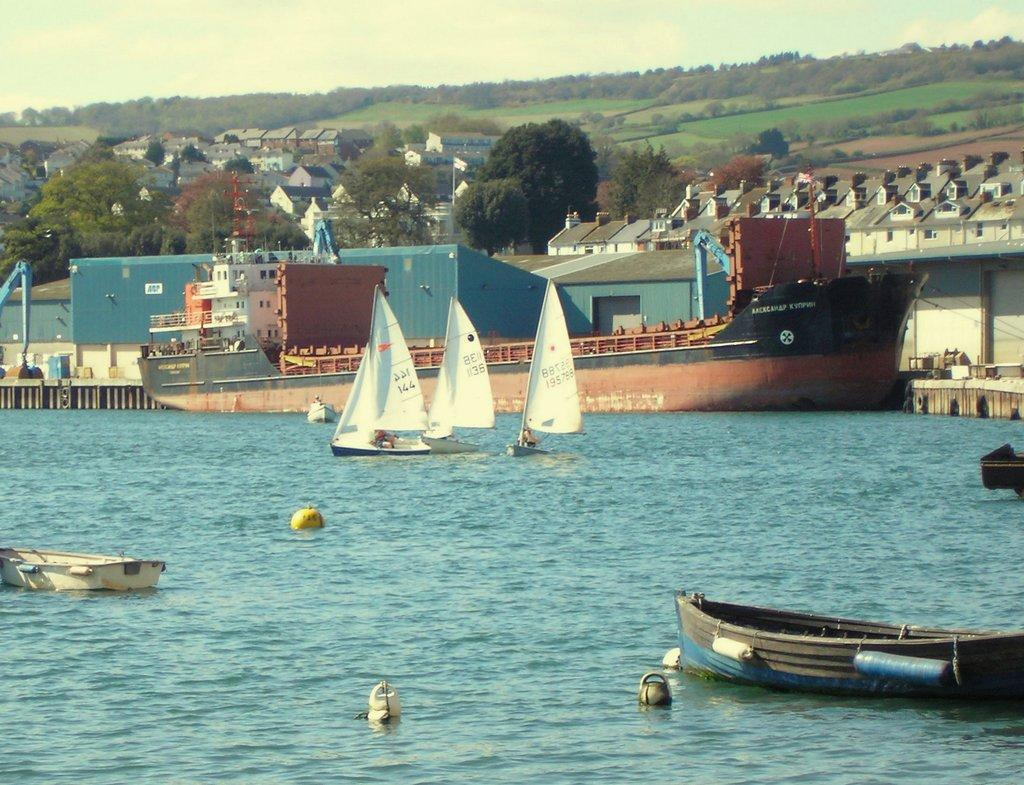What is in the water in the image? There are many boats in the water in the image. What can be seen in the water besides the boats? The water itself is visible in the image. What structures are present in the image? There are buildings in the image. What part of the buildings can be seen? The windows of the buildings are visible. What type of vegetation is present in the image? Trees are present in the image. What type of ground cover is visible in the image? Grass is visible in the image. What part of the natural environment is visible in the image? The sky is visible in the image. What type of fuel is being used by the boats in the image? The image does not provide information about the type of fuel being used by the boats. Is there any poison visible in the image? There is no indication of poison in the image. 